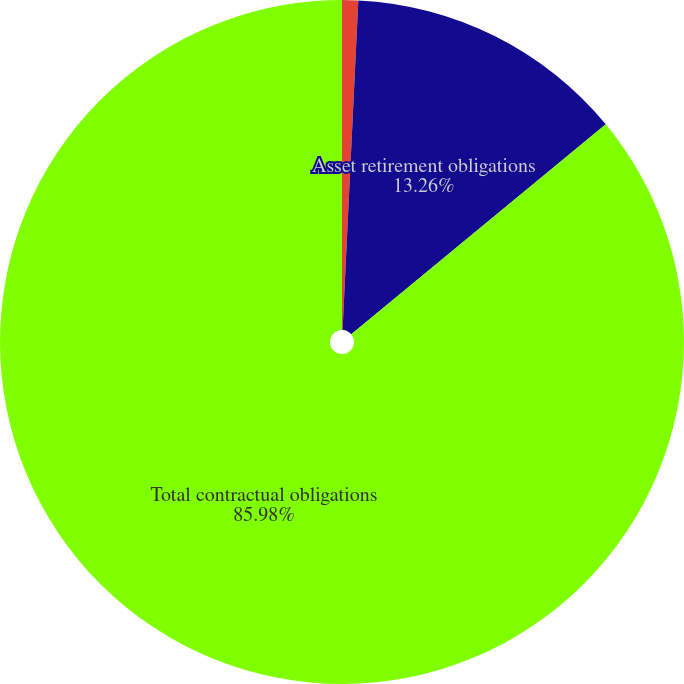Convert chart. <chart><loc_0><loc_0><loc_500><loc_500><pie_chart><fcel>Office buildings and<fcel>Asset retirement obligations<fcel>Total contractual obligations<nl><fcel>0.76%<fcel>13.26%<fcel>85.98%<nl></chart> 